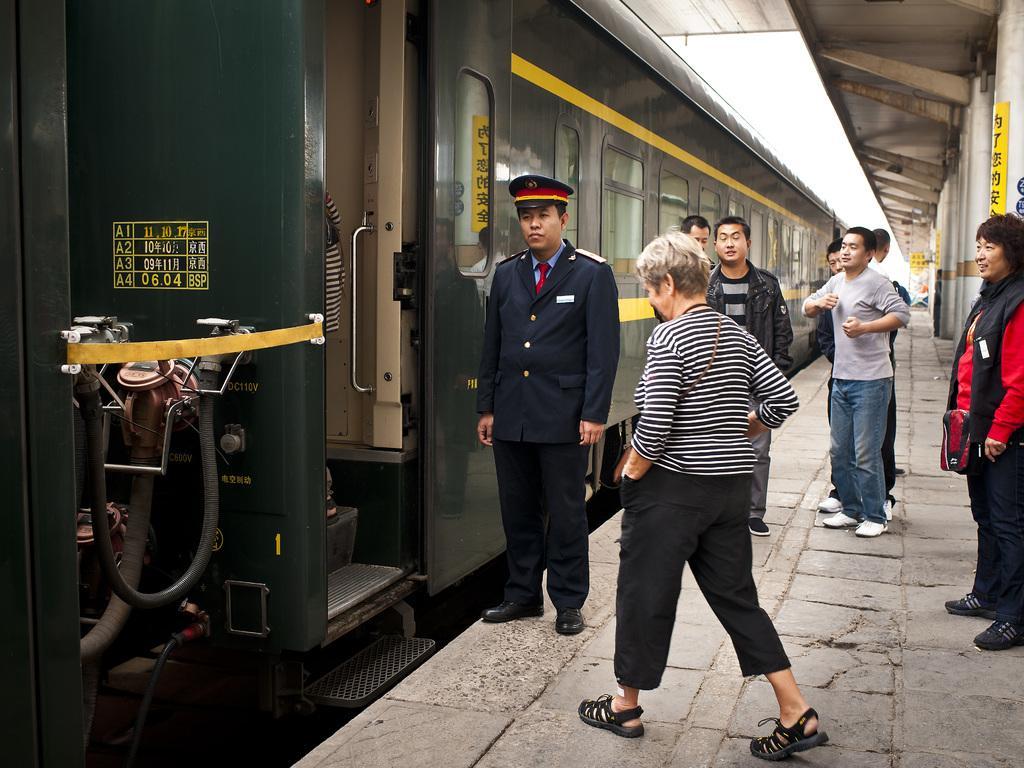Can you describe this image briefly? In this picture there is a train on the left side of the image and there are people and pillars on the right side of the image, there is a roof at the top side of the image, it seems to be there is a cop in the center of the image. 